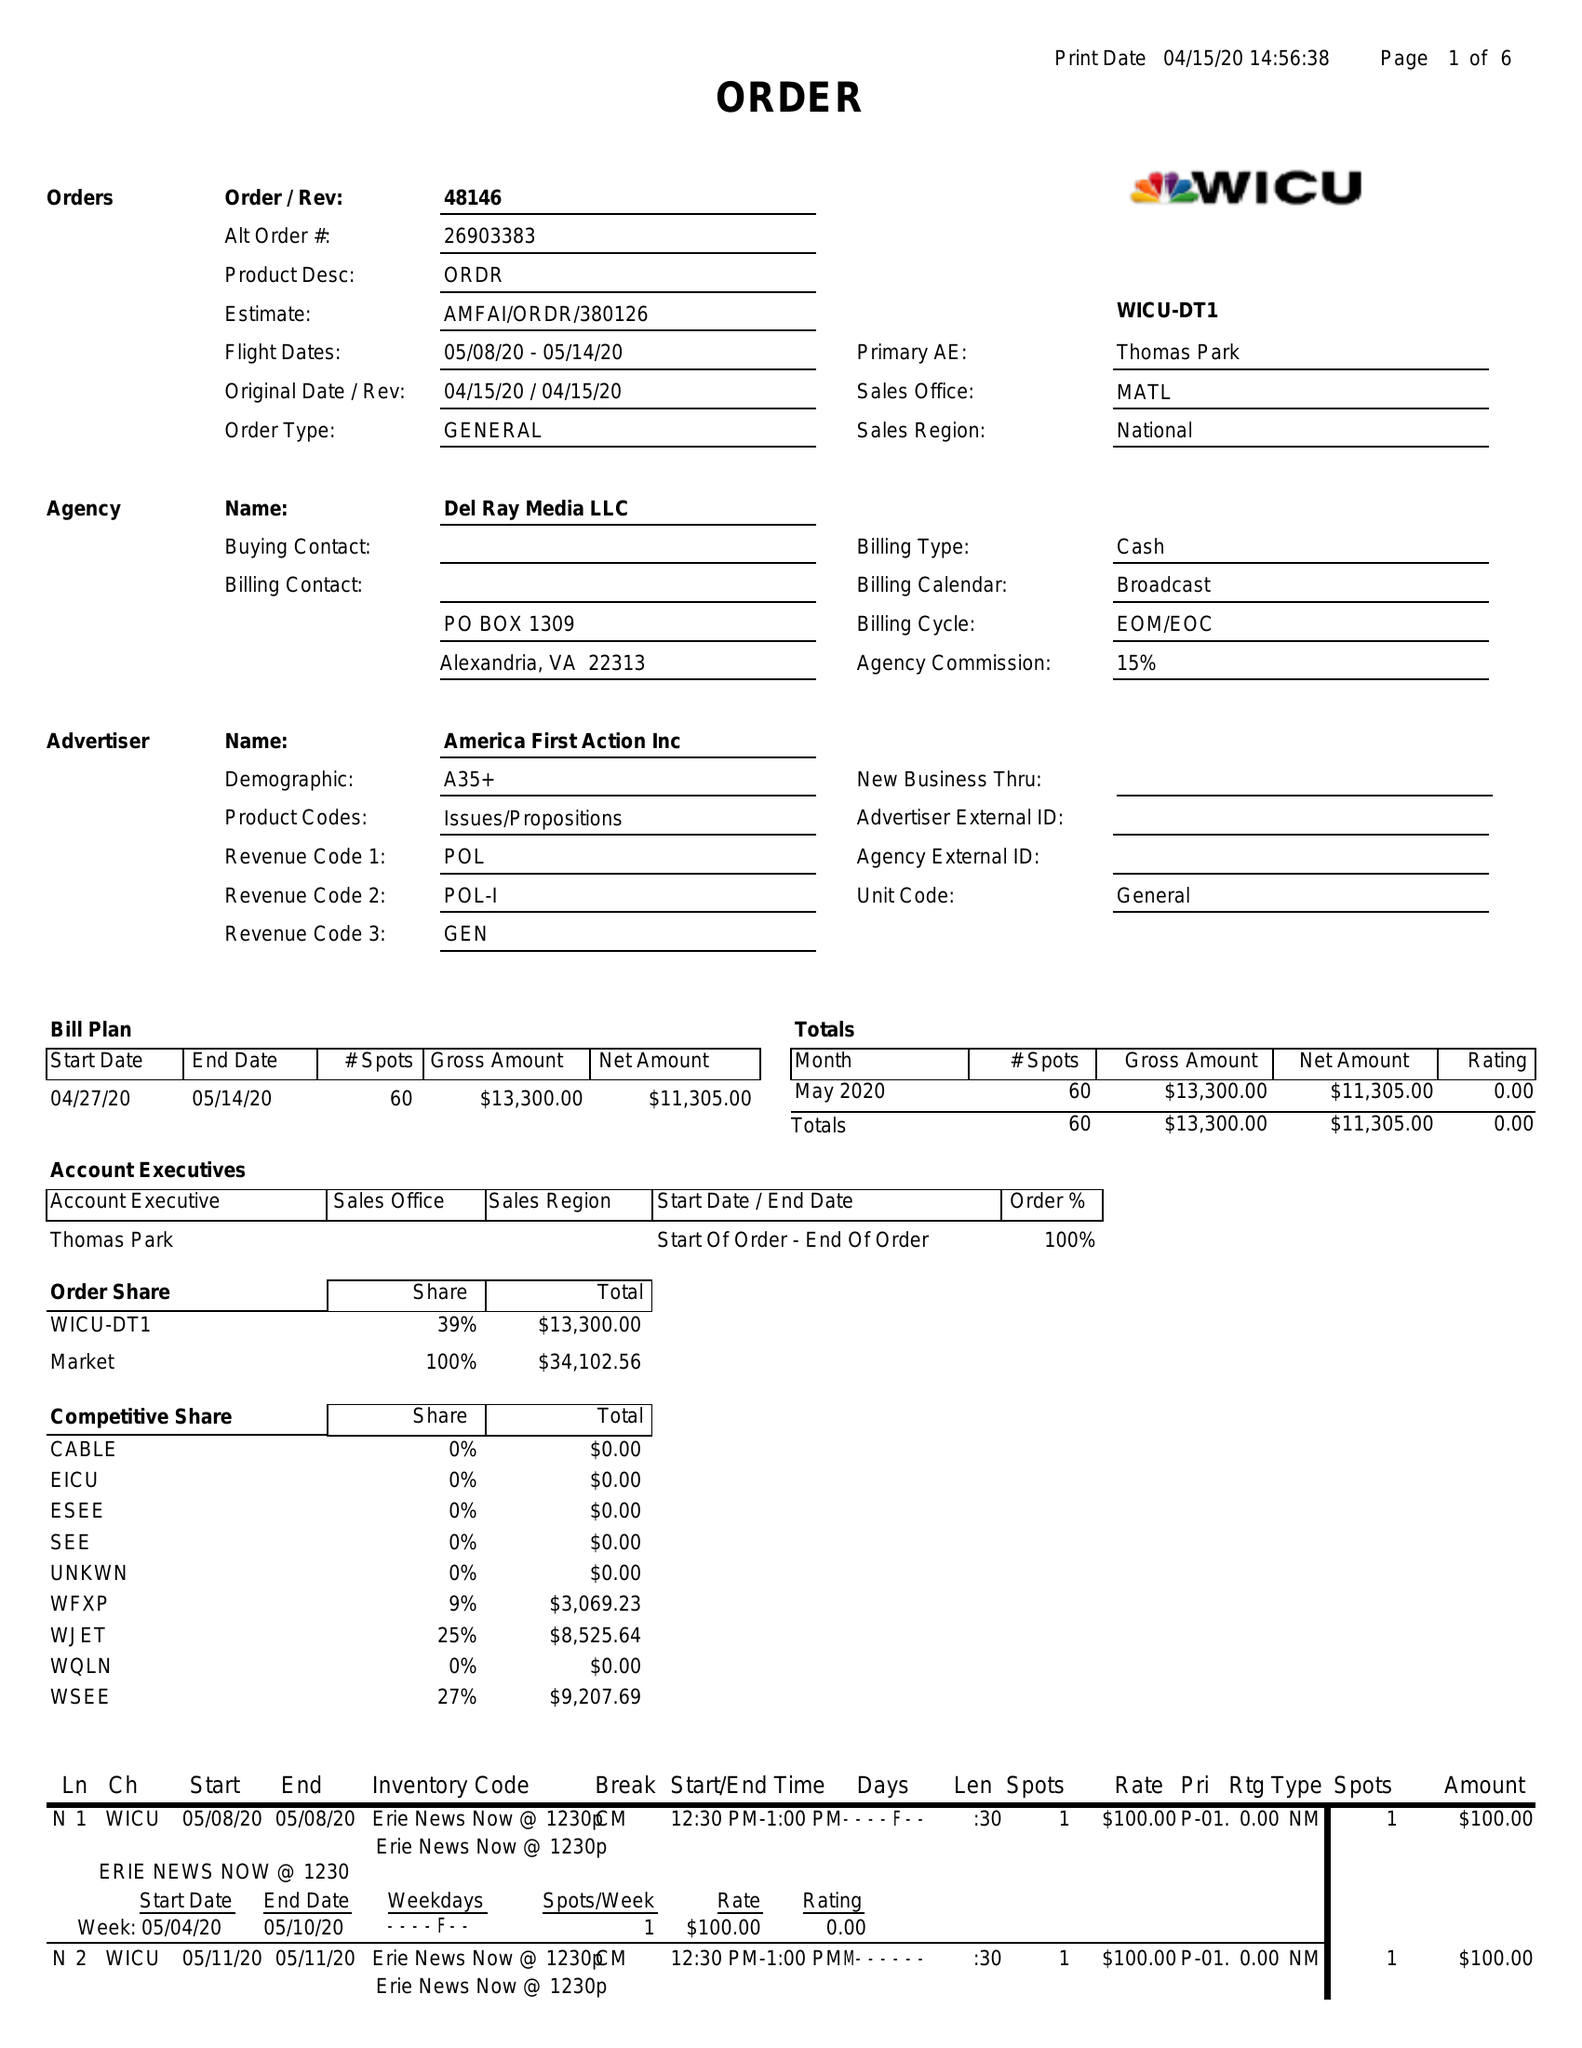What is the value for the flight_to?
Answer the question using a single word or phrase. 05/14/20 